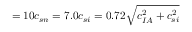Convert formula to latex. <formula><loc_0><loc_0><loc_500><loc_500>= 1 0 c _ { s n } = 7 . 0 c _ { s i } = 0 . 7 2 \sqrt { c _ { I A } ^ { 2 } + c _ { s i } ^ { 2 } }</formula> 